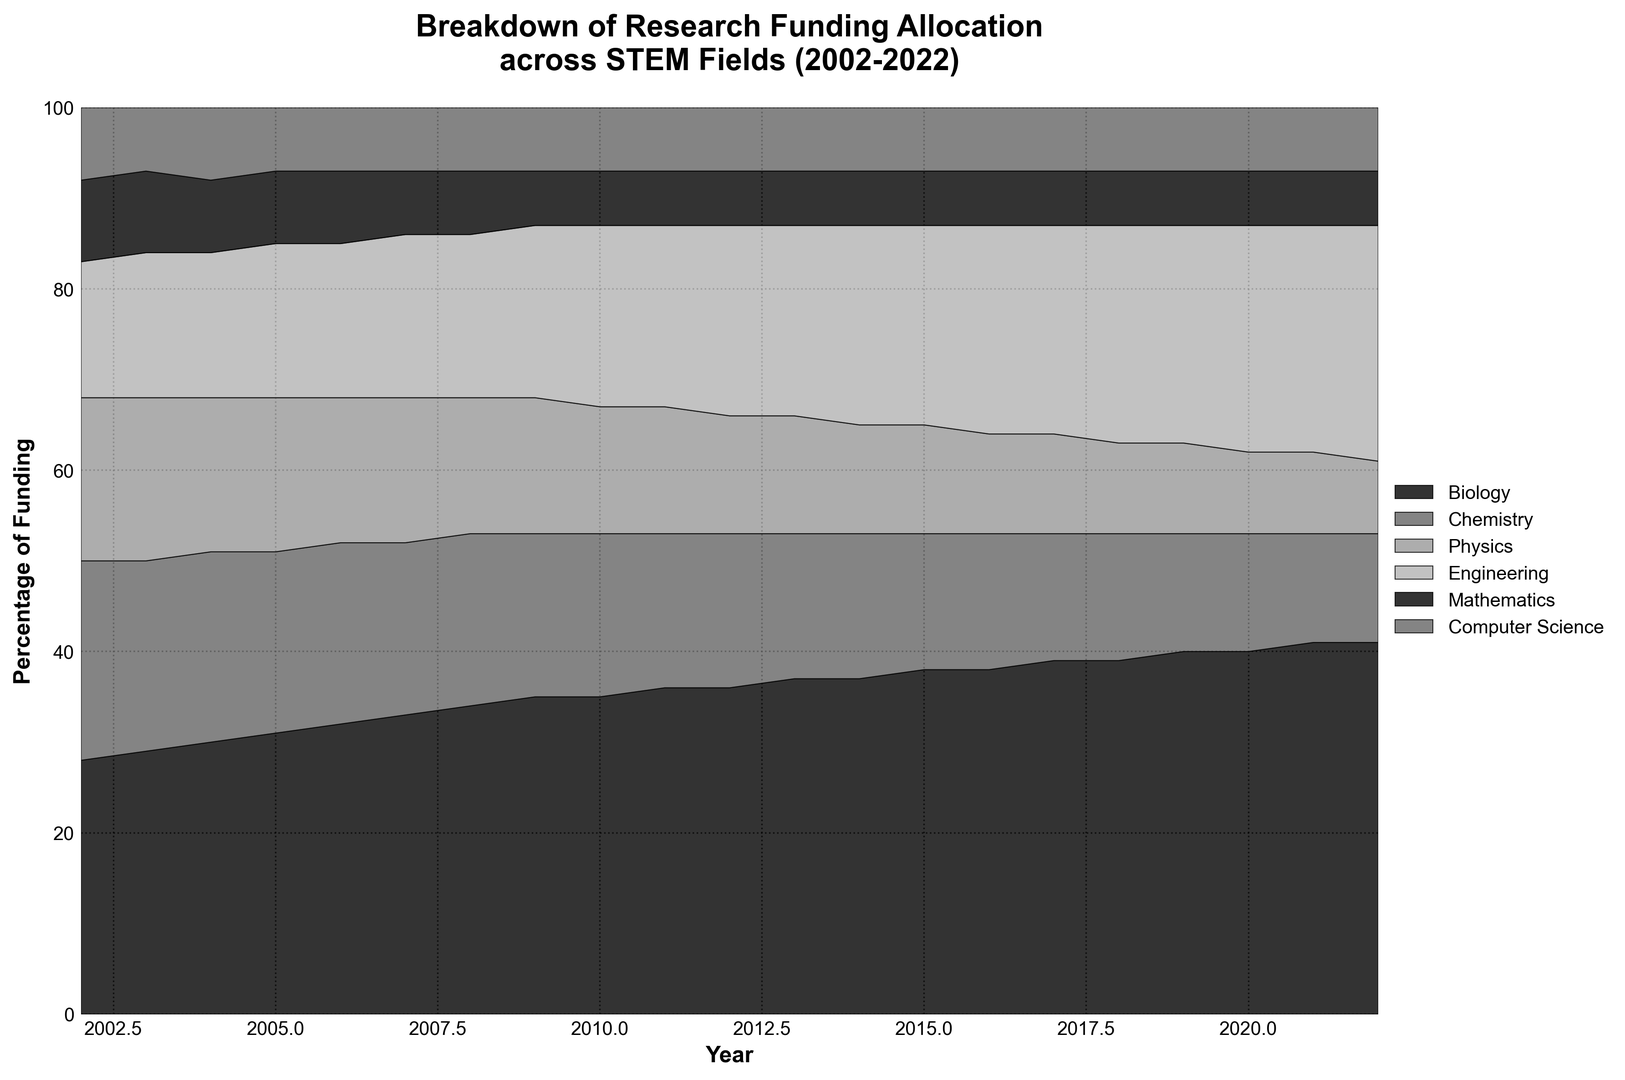What is the general trend of the percentage of funding for Biology over the years? The area allocated to Biology in the chart increases over time. Initially, it starts at 28% in 2002 and gradually grows larger, reaching 41% by 2022.
Answer: Increasing Which STEM field had the highest percentage of funding in 2022? By visually comparing the heights of the different areas in the 2022 segment of the chart, Biology clearly has the highest percentage.
Answer: Biology How has the percentage of funding for Physics changed from 2002 to 2022? In the chart, the area labeled Physics starts at a certain height in 2002 and consistently decreases over time, starting from 18% in 2002 to 8% in 2022.
Answer: Decreased Which years had an increase in funding for Engineering? By following the area for Engineering across the years, we see that there is an increase from 15% in 2002 to 26% in 2022, with notable incremental steps along the way.
Answer: Most years Comparing Chemistry and Computer Science, which field saw a greater reduction in funding percentage by 2022? By examining the change in areas over time, Chemistry decreases from 22% to 12%, whereas Computer Science mostly remains constant at around 7-8%.
Answer: Chemistry In what year did Mathematics funding percentage start to show a decrease? From the chart, the area marked for Mathematics appears steady around 8% until 2007, after which it decreases to 6%.
Answer: 2007 What is the combined percentage of funding for Biology, Chemistry, and Physics in 2022? Summing up the individual percentages for 2022: Biology (41%), Chemistry (12%), Physics (8%). The combined percentage is 41% + 12% + 8%.
Answer: 61% Which field maintained the most stable funding percentage throughout the 20 years? By visually inspecting the areas, Computer Science maintains a constant width between 7% and 8%, indicating stability.
Answer: Computer Science Between which consecutive years did Engineering see the largest increase in funding percentage? By tracking the Engineering area segment year by year, the largest noticeable increase occurs from 2011 to 2012, where it increases from 20% to 21%.
Answer: 2011 to 2012 What was the percentage of funding decrease for Physics from 2002 to 2022? The Physics area starts at 18% in 2002 and ends at 8% in 2022. The decrease is calculated as 18% - 8%.
Answer: 10% 